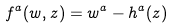<formula> <loc_0><loc_0><loc_500><loc_500>f ^ { a } ( w , z ) = w ^ { a } - h ^ { a } ( z )</formula> 